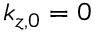<formula> <loc_0><loc_0><loc_500><loc_500>k _ { z , 0 } = 0</formula> 